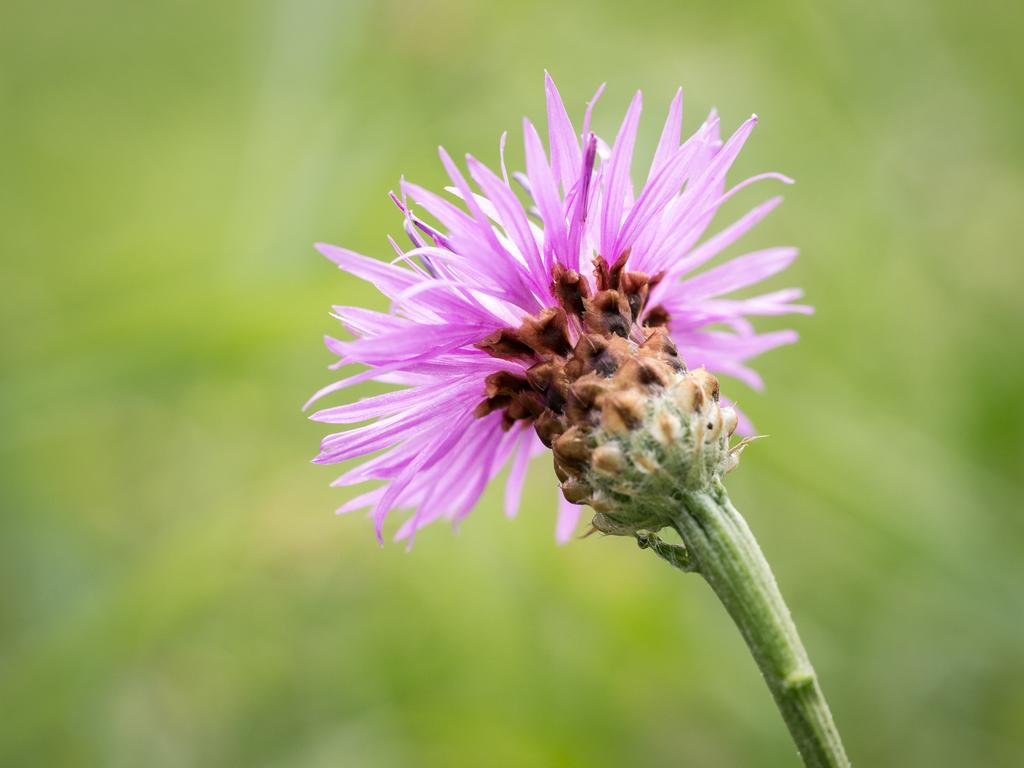What is the main subject of the image? There is a flower in the image. Can you describe the color of the flower? The flower is pink in color. How would you describe the background of the image? The background of the image is blurred. What type of volleyball can be seen in the image? There is no volleyball present in the image. What type of paper is the flower made of in the image? The image is a photograph, and the flower is a real flower, not made of paper. 